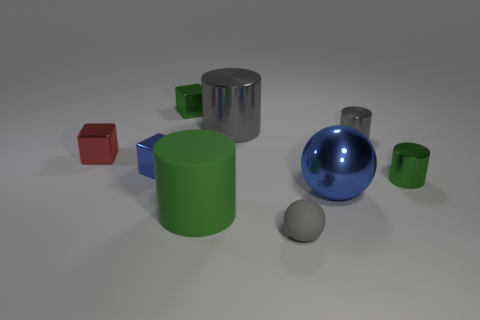Subtract all metallic cylinders. How many cylinders are left? 1 Subtract all green cylinders. How many cylinders are left? 2 Subtract 3 cylinders. How many cylinders are left? 1 Subtract all green cubes. Subtract all red cylinders. How many cubes are left? 2 Subtract all blue cylinders. How many blue spheres are left? 1 Subtract all small purple metal cylinders. Subtract all big objects. How many objects are left? 6 Add 9 large green cylinders. How many large green cylinders are left? 10 Add 4 gray things. How many gray things exist? 7 Subtract 1 green cubes. How many objects are left? 8 Subtract all cubes. How many objects are left? 6 